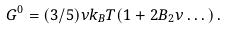<formula> <loc_0><loc_0><loc_500><loc_500>G ^ { 0 } = ( 3 / 5 ) \nu k _ { B } T ( 1 + 2 B _ { 2 } \nu \dots ) \, .</formula> 